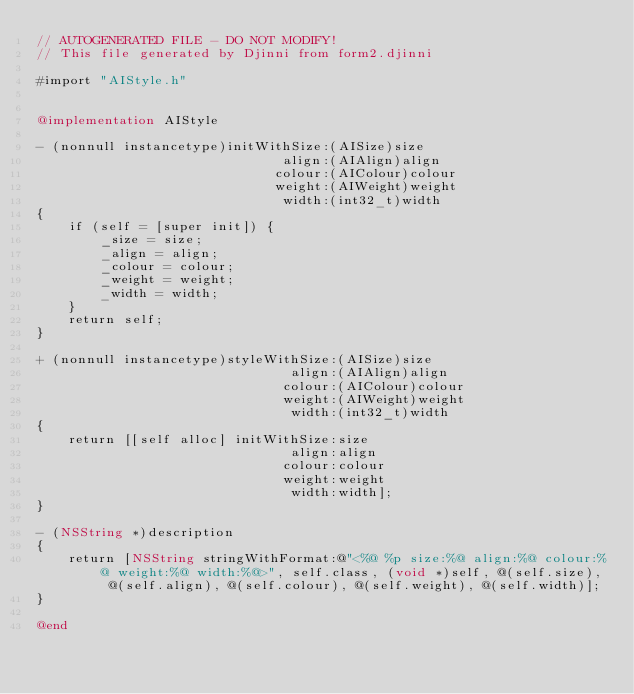<code> <loc_0><loc_0><loc_500><loc_500><_ObjectiveC_>// AUTOGENERATED FILE - DO NOT MODIFY!
// This file generated by Djinni from form2.djinni

#import "AIStyle.h"


@implementation AIStyle

- (nonnull instancetype)initWithSize:(AISize)size
                               align:(AIAlign)align
                              colour:(AIColour)colour
                              weight:(AIWeight)weight
                               width:(int32_t)width
{
    if (self = [super init]) {
        _size = size;
        _align = align;
        _colour = colour;
        _weight = weight;
        _width = width;
    }
    return self;
}

+ (nonnull instancetype)styleWithSize:(AISize)size
                                align:(AIAlign)align
                               colour:(AIColour)colour
                               weight:(AIWeight)weight
                                width:(int32_t)width
{
    return [[self alloc] initWithSize:size
                                align:align
                               colour:colour
                               weight:weight
                                width:width];
}

- (NSString *)description
{
    return [NSString stringWithFormat:@"<%@ %p size:%@ align:%@ colour:%@ weight:%@ width:%@>", self.class, (void *)self, @(self.size), @(self.align), @(self.colour), @(self.weight), @(self.width)];
}

@end
</code> 